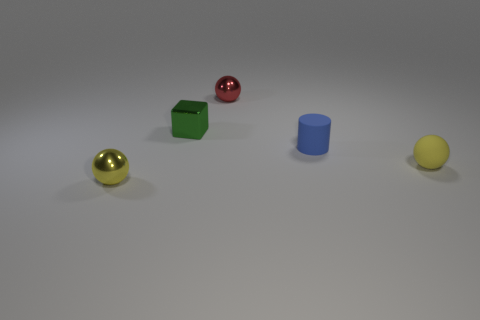Are there any other things that are the same shape as the tiny green thing?
Offer a terse response. No. What number of other things are there of the same size as the blue rubber cylinder?
Make the answer very short. 4. There is a tiny ball that is behind the small yellow metallic thing and in front of the red object; what material is it made of?
Give a very brief answer. Rubber. What number of yellow matte spheres are the same size as the green cube?
Your answer should be compact. 1. There is another yellow thing that is the same shape as the yellow matte object; what is its material?
Provide a succinct answer. Metal. What number of objects are either objects to the left of the red object or tiny balls to the left of the blue rubber object?
Offer a terse response. 3. Is the shape of the small yellow metallic thing the same as the matte object that is to the left of the tiny yellow rubber ball?
Your response must be concise. No. The green metallic thing that is behind the rubber object behind the small yellow thing that is to the right of the blue cylinder is what shape?
Your response must be concise. Cube. How many other things are there of the same material as the red object?
Offer a terse response. 2. What number of things are either yellow things left of the tiny cylinder or yellow rubber cubes?
Give a very brief answer. 1. 